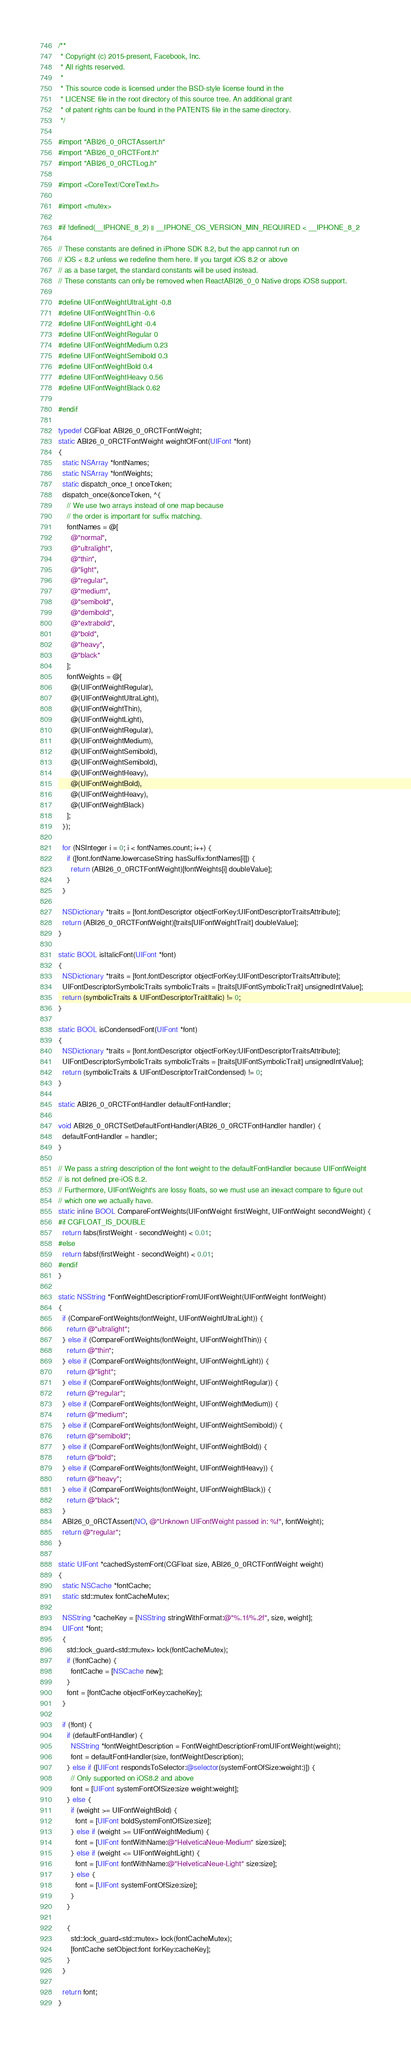<code> <loc_0><loc_0><loc_500><loc_500><_ObjectiveC_>/**
 * Copyright (c) 2015-present, Facebook, Inc.
 * All rights reserved.
 *
 * This source code is licensed under the BSD-style license found in the
 * LICENSE file in the root directory of this source tree. An additional grant
 * of patent rights can be found in the PATENTS file in the same directory.
 */

#import "ABI26_0_0RCTAssert.h"
#import "ABI26_0_0RCTFont.h"
#import "ABI26_0_0RCTLog.h"

#import <CoreText/CoreText.h>

#import <mutex>

#if !defined(__IPHONE_8_2) || __IPHONE_OS_VERSION_MIN_REQUIRED < __IPHONE_8_2

// These constants are defined in iPhone SDK 8.2, but the app cannot run on
// iOS < 8.2 unless we redefine them here. If you target iOS 8.2 or above
// as a base target, the standard constants will be used instead.
// These constants can only be removed when ReactABI26_0_0 Native drops iOS8 support.

#define UIFontWeightUltraLight -0.8
#define UIFontWeightThin -0.6
#define UIFontWeightLight -0.4
#define UIFontWeightRegular 0
#define UIFontWeightMedium 0.23
#define UIFontWeightSemibold 0.3
#define UIFontWeightBold 0.4
#define UIFontWeightHeavy 0.56
#define UIFontWeightBlack 0.62

#endif

typedef CGFloat ABI26_0_0RCTFontWeight;
static ABI26_0_0RCTFontWeight weightOfFont(UIFont *font)
{
  static NSArray *fontNames;
  static NSArray *fontWeights;
  static dispatch_once_t onceToken;
  dispatch_once(&onceToken, ^{
    // We use two arrays instead of one map because
    // the order is important for suffix matching.
    fontNames = @[
      @"normal",
      @"ultralight",
      @"thin",
      @"light",
      @"regular",
      @"medium",
      @"semibold",
      @"demibold",
      @"extrabold",
      @"bold",
      @"heavy",
      @"black"
    ];
    fontWeights = @[
      @(UIFontWeightRegular),
      @(UIFontWeightUltraLight),
      @(UIFontWeightThin),
      @(UIFontWeightLight),
      @(UIFontWeightRegular),
      @(UIFontWeightMedium),
      @(UIFontWeightSemibold),
      @(UIFontWeightSemibold),
      @(UIFontWeightHeavy),
      @(UIFontWeightBold),
      @(UIFontWeightHeavy),
      @(UIFontWeightBlack)
    ];
  });

  for (NSInteger i = 0; i < fontNames.count; i++) {
    if ([font.fontName.lowercaseString hasSuffix:fontNames[i]]) {
      return (ABI26_0_0RCTFontWeight)[fontWeights[i] doubleValue];
    }
  }

  NSDictionary *traits = [font.fontDescriptor objectForKey:UIFontDescriptorTraitsAttribute];
  return (ABI26_0_0RCTFontWeight)[traits[UIFontWeightTrait] doubleValue];
}

static BOOL isItalicFont(UIFont *font)
{
  NSDictionary *traits = [font.fontDescriptor objectForKey:UIFontDescriptorTraitsAttribute];
  UIFontDescriptorSymbolicTraits symbolicTraits = [traits[UIFontSymbolicTrait] unsignedIntValue];
  return (symbolicTraits & UIFontDescriptorTraitItalic) != 0;
}

static BOOL isCondensedFont(UIFont *font)
{
  NSDictionary *traits = [font.fontDescriptor objectForKey:UIFontDescriptorTraitsAttribute];
  UIFontDescriptorSymbolicTraits symbolicTraits = [traits[UIFontSymbolicTrait] unsignedIntValue];
  return (symbolicTraits & UIFontDescriptorTraitCondensed) != 0;
}

static ABI26_0_0RCTFontHandler defaultFontHandler;

void ABI26_0_0RCTSetDefaultFontHandler(ABI26_0_0RCTFontHandler handler) {
  defaultFontHandler = handler;
}

// We pass a string description of the font weight to the defaultFontHandler because UIFontWeight
// is not defined pre-iOS 8.2.
// Furthermore, UIFontWeight's are lossy floats, so we must use an inexact compare to figure out
// which one we actually have.
static inline BOOL CompareFontWeights(UIFontWeight firstWeight, UIFontWeight secondWeight) {
#if CGFLOAT_IS_DOUBLE
  return fabs(firstWeight - secondWeight) < 0.01;
#else
  return fabsf(firstWeight - secondWeight) < 0.01;
#endif
}

static NSString *FontWeightDescriptionFromUIFontWeight(UIFontWeight fontWeight)
{
  if (CompareFontWeights(fontWeight, UIFontWeightUltraLight)) {
    return @"ultralight";
  } else if (CompareFontWeights(fontWeight, UIFontWeightThin)) {
    return @"thin";
  } else if (CompareFontWeights(fontWeight, UIFontWeightLight)) {
    return @"light";
  } else if (CompareFontWeights(fontWeight, UIFontWeightRegular)) {
    return @"regular";
  } else if (CompareFontWeights(fontWeight, UIFontWeightMedium)) {
    return @"medium";
  } else if (CompareFontWeights(fontWeight, UIFontWeightSemibold)) {
    return @"semibold";
  } else if (CompareFontWeights(fontWeight, UIFontWeightBold)) {
    return @"bold";
  } else if (CompareFontWeights(fontWeight, UIFontWeightHeavy)) {
    return @"heavy";
  } else if (CompareFontWeights(fontWeight, UIFontWeightBlack)) {
    return @"black";
  }
  ABI26_0_0RCTAssert(NO, @"Unknown UIFontWeight passed in: %f", fontWeight);
  return @"regular";
}

static UIFont *cachedSystemFont(CGFloat size, ABI26_0_0RCTFontWeight weight)
{
  static NSCache *fontCache;
  static std::mutex fontCacheMutex;

  NSString *cacheKey = [NSString stringWithFormat:@"%.1f/%.2f", size, weight];
  UIFont *font;
  {
    std::lock_guard<std::mutex> lock(fontCacheMutex);
    if (!fontCache) {
      fontCache = [NSCache new];
    }
    font = [fontCache objectForKey:cacheKey];
  }

  if (!font) {
    if (defaultFontHandler) {
      NSString *fontWeightDescription = FontWeightDescriptionFromUIFontWeight(weight);
      font = defaultFontHandler(size, fontWeightDescription);
    } else if ([UIFont respondsToSelector:@selector(systemFontOfSize:weight:)]) {
      // Only supported on iOS8.2 and above
      font = [UIFont systemFontOfSize:size weight:weight];
    } else {
      if (weight >= UIFontWeightBold) {
        font = [UIFont boldSystemFontOfSize:size];
      } else if (weight >= UIFontWeightMedium) {
        font = [UIFont fontWithName:@"HelveticaNeue-Medium" size:size];
      } else if (weight <= UIFontWeightLight) {
        font = [UIFont fontWithName:@"HelveticaNeue-Light" size:size];
      } else {
        font = [UIFont systemFontOfSize:size];
      }
    }

    {
      std::lock_guard<std::mutex> lock(fontCacheMutex);
      [fontCache setObject:font forKey:cacheKey];
    }
  }

  return font;
}
</code> 